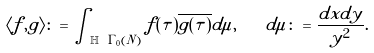Convert formula to latex. <formula><loc_0><loc_0><loc_500><loc_500>\langle f , g \rangle \colon = \int _ { \mathbb { H } \ \Gamma _ { 0 } ( N ) } f ( \tau ) \overline { g ( \tau ) } d \mu , \quad d \mu \colon = \frac { d x d y } { y ^ { 2 } } .</formula> 